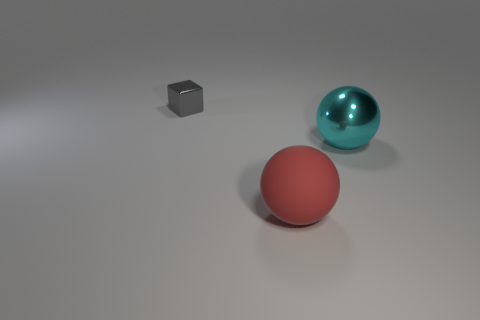Is there any other thing that has the same size as the gray object?
Your answer should be compact. No. What number of large purple metal objects are there?
Make the answer very short. 0. What material is the object behind the metallic object that is in front of the small metal cube made of?
Offer a terse response. Metal. The large sphere that is the same material as the gray block is what color?
Your answer should be compact. Cyan. Is the size of the sphere that is on the left side of the big cyan metallic ball the same as the metallic object behind the big metallic sphere?
Your response must be concise. No. What number of spheres are either large things or cyan shiny objects?
Offer a terse response. 2. Are the thing to the right of the red rubber object and the cube made of the same material?
Provide a succinct answer. Yes. What number of other things are there of the same size as the matte object?
Provide a short and direct response. 1. What number of small things are cyan things or metallic blocks?
Your answer should be very brief. 1. Are there more large red rubber spheres behind the small gray shiny object than rubber objects that are in front of the cyan thing?
Your answer should be compact. No. 